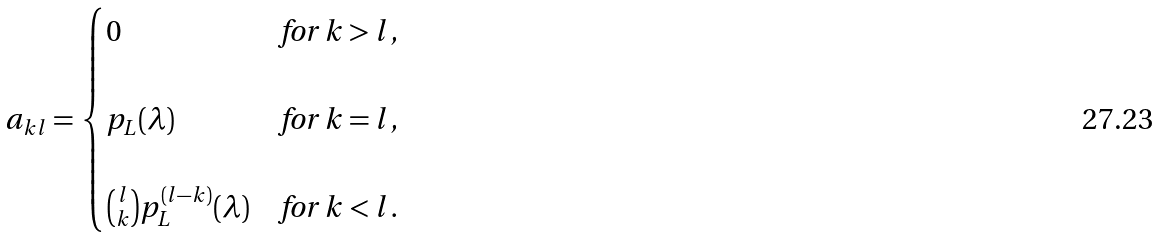<formula> <loc_0><loc_0><loc_500><loc_500>a _ { k l } = \begin{cases} 0 & \text {for $k > l$,} \\ \\ p _ { L } ( \lambda ) & \text {for $k = l$,} \\ \\ \binom { l } { k } p _ { L } ^ { ( l - k ) } ( \lambda ) & \text {for $k < l$.} \\ \end{cases}</formula> 